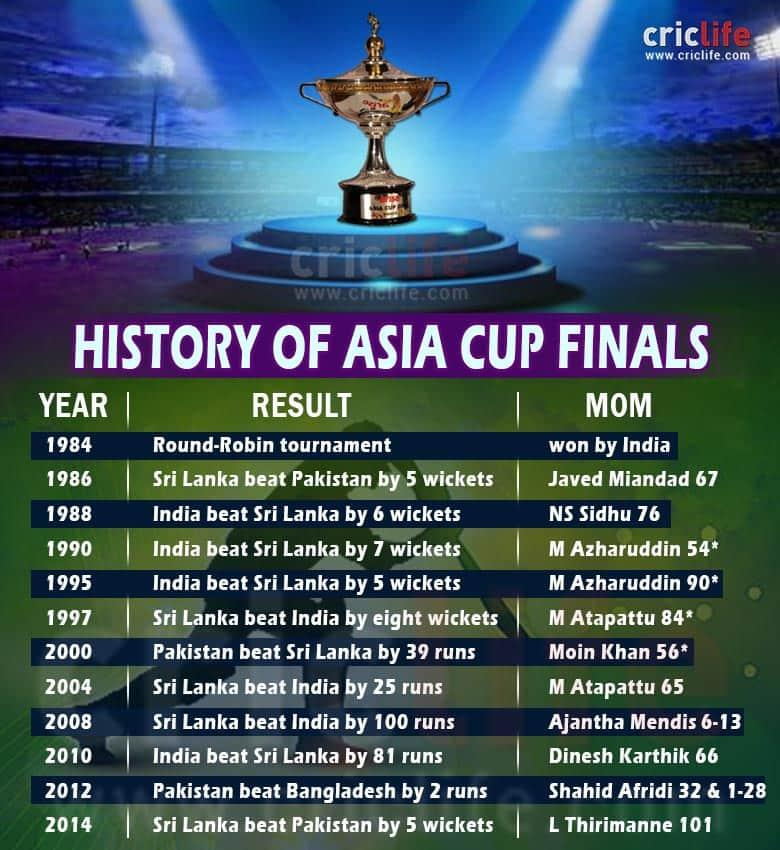Outline some significant characteristics in this image. I am able to name the players who have won the "MOM" award twice, including M Azharuddin and M Atapattu. The total number of years that the Asia Cup was held between 1984 and 2014 was 12. India and Sri Lanka are the countries that have won the Asia Cup five times each. In the match won by India in 1990, the team defeated Sri Lanka by the most number of wickets. Sri Lanka has won the Asia Cup the most times after 2000. 